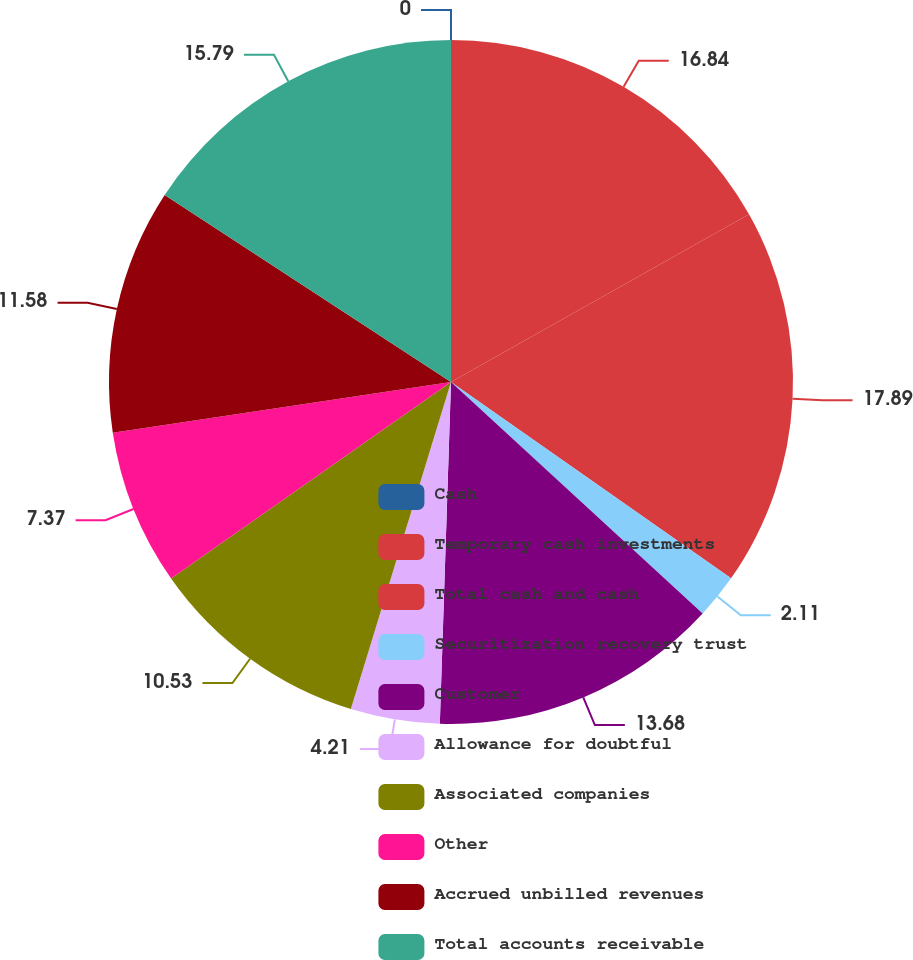Convert chart to OTSL. <chart><loc_0><loc_0><loc_500><loc_500><pie_chart><fcel>Cash<fcel>Temporary cash investments<fcel>Total cash and cash<fcel>Securitization recovery trust<fcel>Customer<fcel>Allowance for doubtful<fcel>Associated companies<fcel>Other<fcel>Accrued unbilled revenues<fcel>Total accounts receivable<nl><fcel>0.0%<fcel>16.84%<fcel>17.89%<fcel>2.11%<fcel>13.68%<fcel>4.21%<fcel>10.53%<fcel>7.37%<fcel>11.58%<fcel>15.79%<nl></chart> 